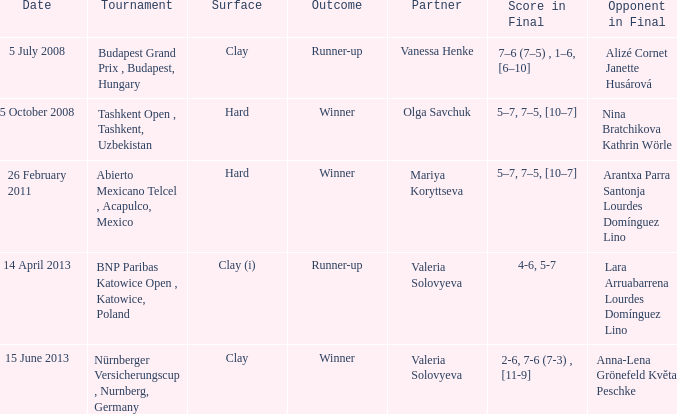Give me the full table as a dictionary. {'header': ['Date', 'Tournament', 'Surface', 'Outcome', 'Partner', 'Score in Final', 'Opponent in Final'], 'rows': [['5 July 2008', 'Budapest Grand Prix , Budapest, Hungary', 'Clay', 'Runner-up', 'Vanessa Henke', '7–6 (7–5) , 1–6, [6–10]', 'Alizé Cornet Janette Husárová'], ['5 October 2008', 'Tashkent Open , Tashkent, Uzbekistan', 'Hard', 'Winner', 'Olga Savchuk', '5–7, 7–5, [10–7]', 'Nina Bratchikova Kathrin Wörle'], ['26 February 2011', 'Abierto Mexicano Telcel , Acapulco, Mexico', 'Hard', 'Winner', 'Mariya Koryttseva', '5–7, 7–5, [10–7]', 'Arantxa Parra Santonja Lourdes Domínguez Lino'], ['14 April 2013', 'BNP Paribas Katowice Open , Katowice, Poland', 'Clay (i)', 'Runner-up', 'Valeria Solovyeva', '4-6, 5-7', 'Lara Arruabarrena Lourdes Domínguez Lino'], ['15 June 2013', 'Nürnberger Versicherungscup , Nurnberg, Germany', 'Clay', 'Winner', 'Valeria Solovyeva', '2-6, 7-6 (7-3) , [11-9]', 'Anna-Lena Grönefeld Květa Peschke']]} Which partner was on 14 april 2013? Valeria Solovyeva. 